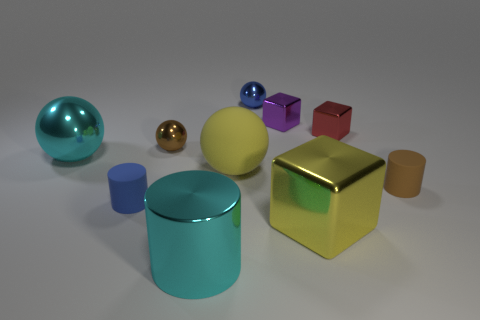There is a big cylinder; is it the same color as the big metal thing that is on the left side of the shiny cylinder?
Your answer should be very brief. Yes. There is a tiny cylinder left of the yellow block; how many blue shiny things are right of it?
Your answer should be compact. 1. There is a metal block that is both behind the brown ball and to the right of the purple shiny object; what size is it?
Provide a short and direct response. Small. Is there a red rubber cylinder of the same size as the purple shiny object?
Make the answer very short. No. Are there more tiny blue cylinders to the left of the small purple cube than big yellow objects that are to the left of the large yellow rubber sphere?
Your answer should be compact. Yes. Are the small purple cube and the cube that is to the right of the big shiny block made of the same material?
Your response must be concise. Yes. How many big yellow metallic objects are in front of the yellow object that is in front of the small cylinder that is on the left side of the tiny brown sphere?
Give a very brief answer. 0. There is a purple metal thing; is it the same shape as the big yellow thing to the left of the purple thing?
Your answer should be compact. No. What color is the metallic sphere that is both right of the cyan shiny sphere and in front of the tiny red block?
Offer a very short reply. Brown. What material is the small brown thing that is left of the tiny brown thing that is right of the tiny blue metal ball that is to the right of the brown metal thing?
Provide a short and direct response. Metal. 